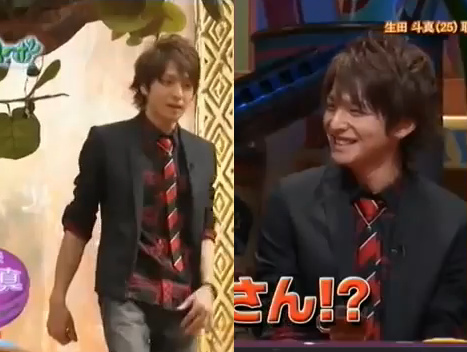What kind of clothing is not folded? The shirt is not folded. 